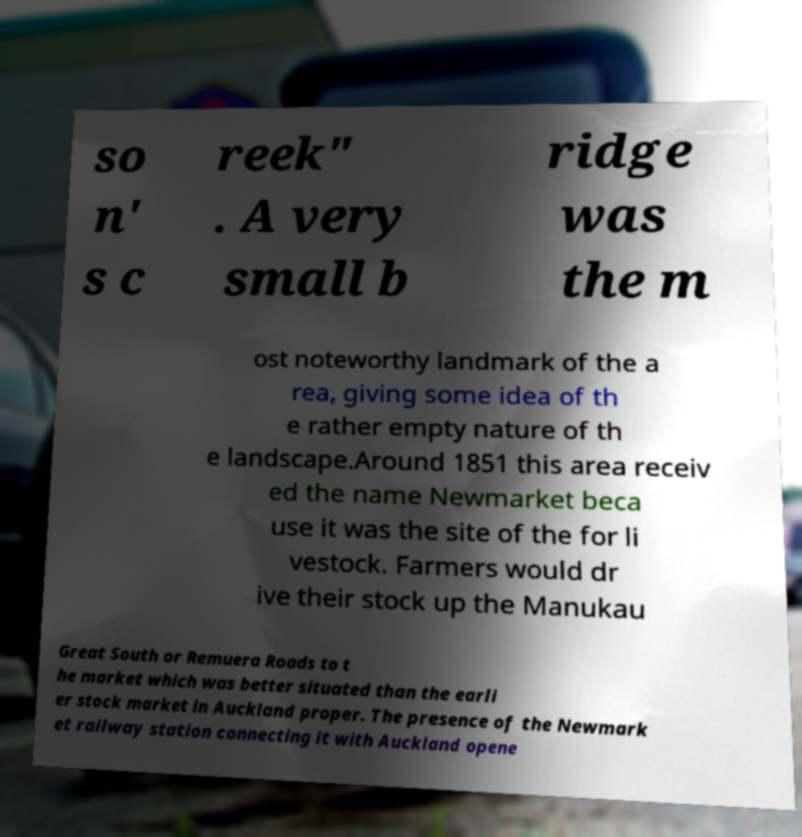Can you read and provide the text displayed in the image?This photo seems to have some interesting text. Can you extract and type it out for me? so n' s c reek" . A very small b ridge was the m ost noteworthy landmark of the a rea, giving some idea of th e rather empty nature of th e landscape.Around 1851 this area receiv ed the name Newmarket beca use it was the site of the for li vestock. Farmers would dr ive their stock up the Manukau Great South or Remuera Roads to t he market which was better situated than the earli er stock market in Auckland proper. The presence of the Newmark et railway station connecting it with Auckland opene 